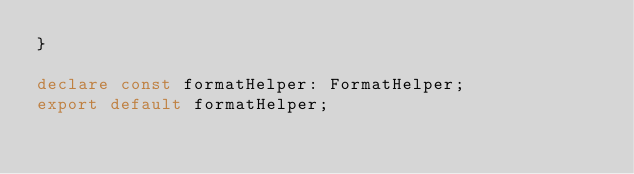Convert code to text. <code><loc_0><loc_0><loc_500><loc_500><_TypeScript_>}

declare const formatHelper: FormatHelper;
export default formatHelper;
</code> 